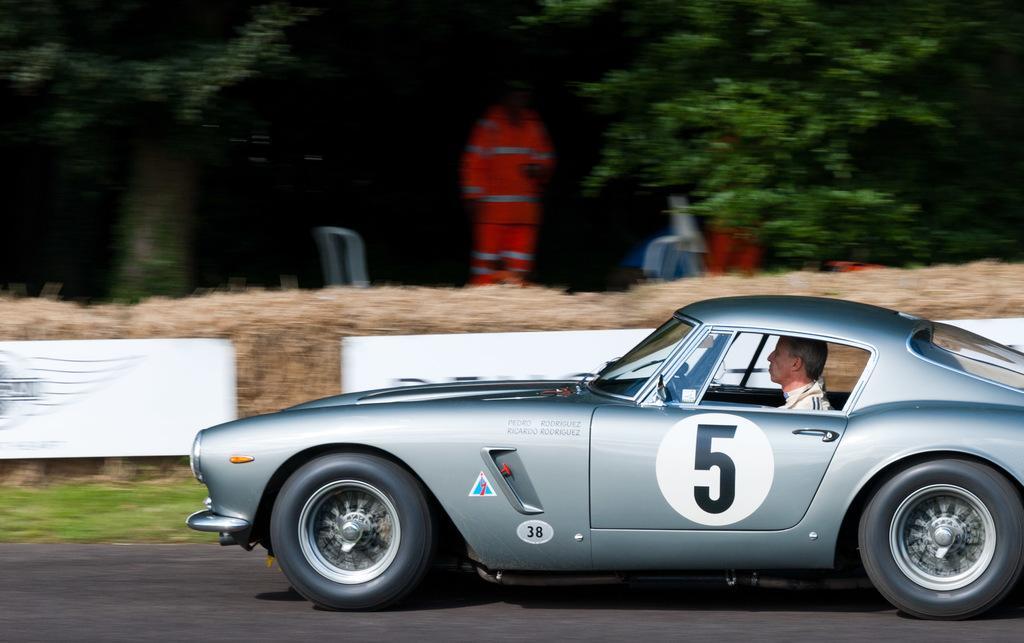How would you summarize this image in a sentence or two? In the given image we can see a car and a person is sitting inside the car. This is a road, grass. There are few more people who are standing and watching. 